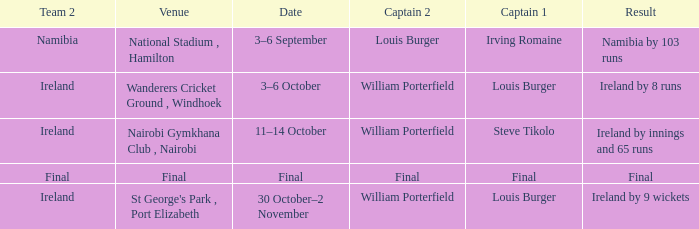Which Captain 2 has a Result of final? Final. 